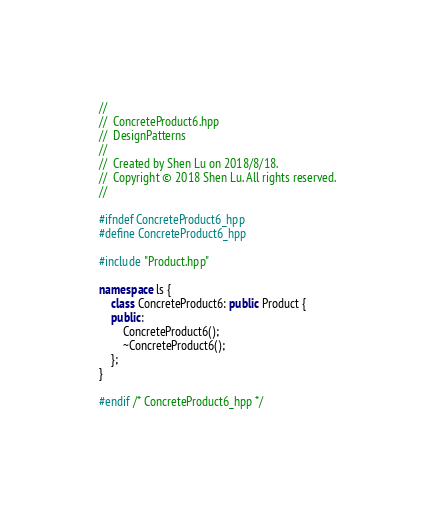<code> <loc_0><loc_0><loc_500><loc_500><_C++_>//
//  ConcreteProduct6.hpp
//  DesignPatterns
//
//  Created by Shen Lu on 2018/8/18.
//  Copyright © 2018 Shen Lu. All rights reserved.
//

#ifndef ConcreteProduct6_hpp
#define ConcreteProduct6_hpp

#include "Product.hpp"

namespace ls {
    class ConcreteProduct6: public Product {
    public:
        ConcreteProduct6();
        ~ConcreteProduct6();
    };
}

#endif /* ConcreteProduct6_hpp */
</code> 